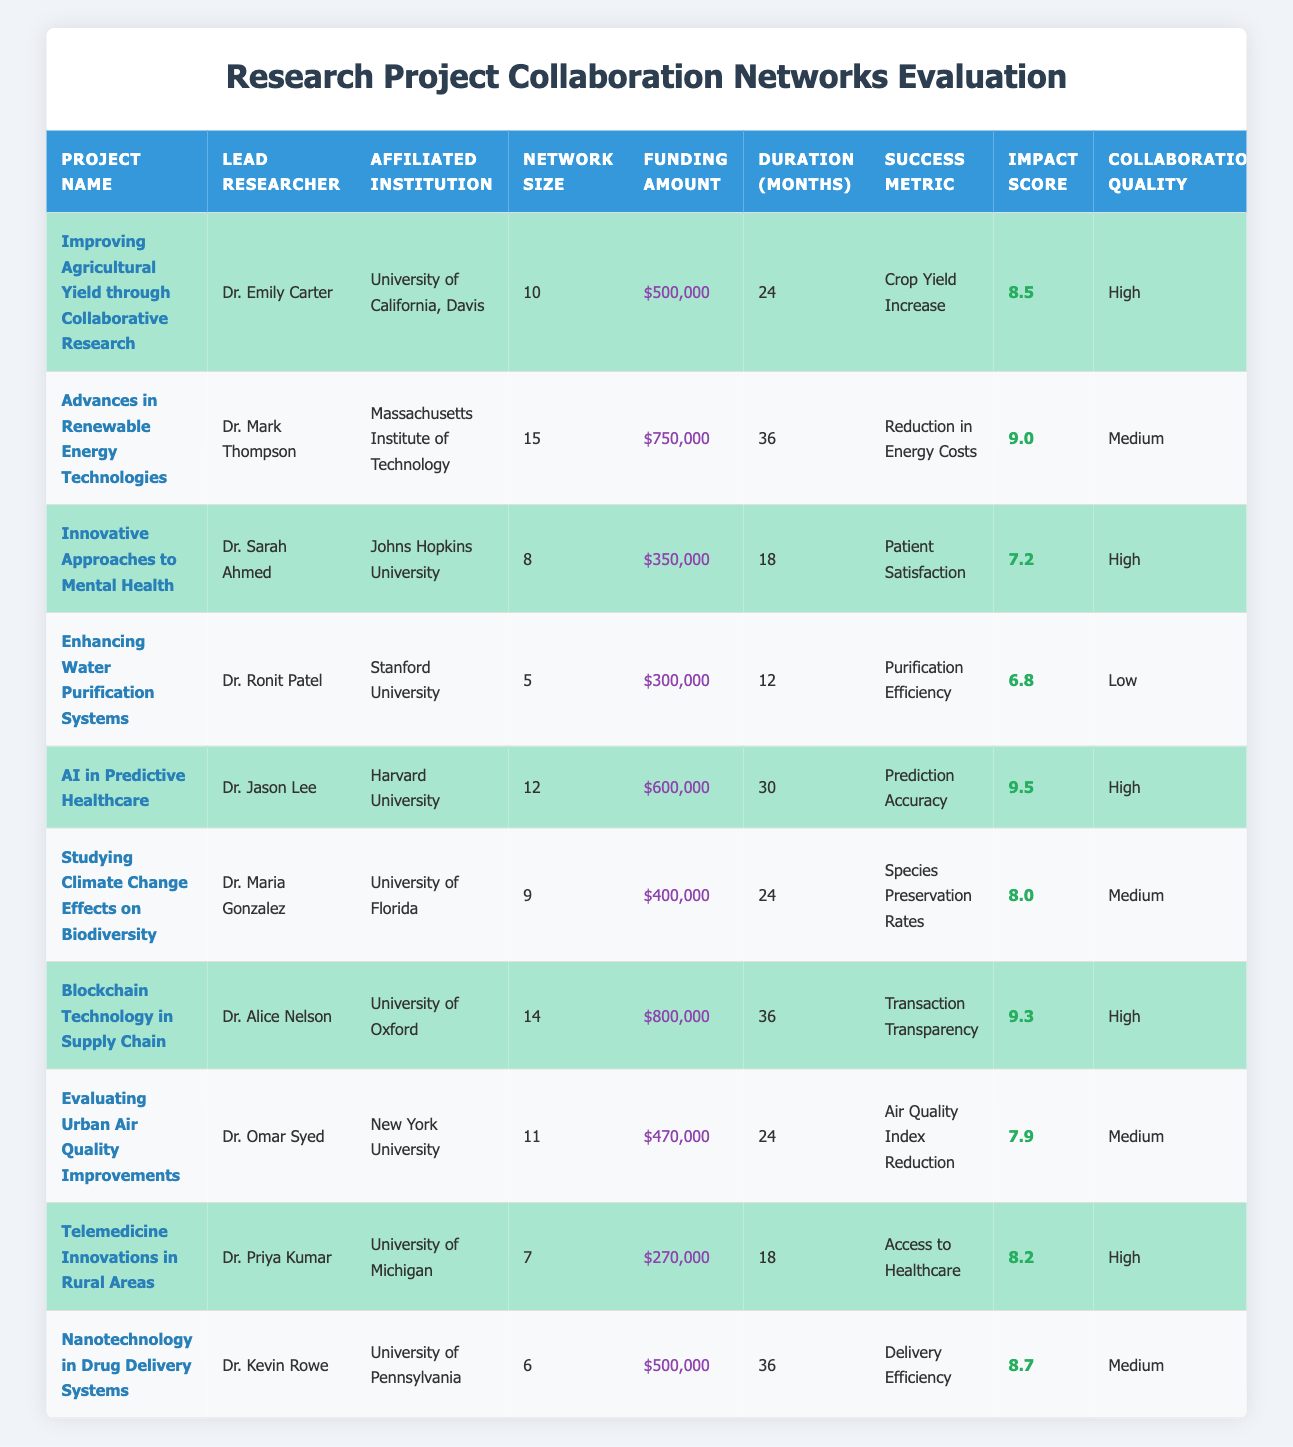What project has the highest impact score? Looking at the "Impact Score" column, I can see that "AI in Predictive Healthcare" has the highest score of 9.5.
Answer: AI in Predictive Healthcare Which project received the least funding? From the "Funding Amount" column, "Telemedicine Innovations in Rural Areas" received the least funding at $270,000.
Answer: $270,000 What is the average duration of the projects listed? I can calculate the average duration by summing the durations (24 + 36 + 18 + 12 + 30 + 24 + 36 + 24 + 18 + 36 =  252 months) and dividing by the number of projects (10). So, 252 / 10 = 25.2.
Answer: 25.2 months Is there a project with a collaboration quality labeled as "Low"? Yes, "Enhancing Water Purification Systems" is labeled as having "Low" collaboration quality.
Answer: Yes Which project has both high collaboration quality and the longest duration? Among the high collaboration quality projects, I assess the durations: 24 (P001), 18 (P003), 30 (P005), 36 (P007), 24 (P009). The longest duration is 36 months for "Blockchain Technology in Supply Chain."
Answer: Blockchain Technology in Supply Chain How many projects have a collaboration network size greater than 10? The projects with a network size greater than 10 are: "Advances in Renewable Energy Technologies" (15), "AI in Predictive Healthcare" (12), "Blockchain Technology in Supply Chain" (14), and "Evaluating Urban Air Quality Improvements" (11). There are 4 such projects.
Answer: 4 What is the total funding amount for all projects with a high impact score? The projects with high impact scores are: "Improving Agricultural Yield through Collaborative Research" ($500,000), "AI in Predictive Healthcare" ($600,000), "Blockchain Technology in Supply Chain" ($800,000), and "Telemedicine Innovations in Rural Areas" ($270,000). Adding these gives $500,000 + $600,000 + $800,000 + $270,000 = $2,170,000.
Answer: $2,170,000 Which researcher leads the project with the highest collaboration network size? The project with the highest collaboration network size is "Advances in Renewable Energy Technologies," led by Dr. Mark Thompson who has a network size of 15.
Answer: Dr. Mark Thompson Do any projects have a duration of less than 18 months? Yes, "Enhancing Water Purification Systems" has a duration of 12 months, which is less than 18 months.
Answer: Yes What percentage of the projects list "High" collaboration quality? Out of the 10 projects, there are 5 with "High" collaboration quality, so the percentage is (5/10) * 100 = 50%.
Answer: 50% 